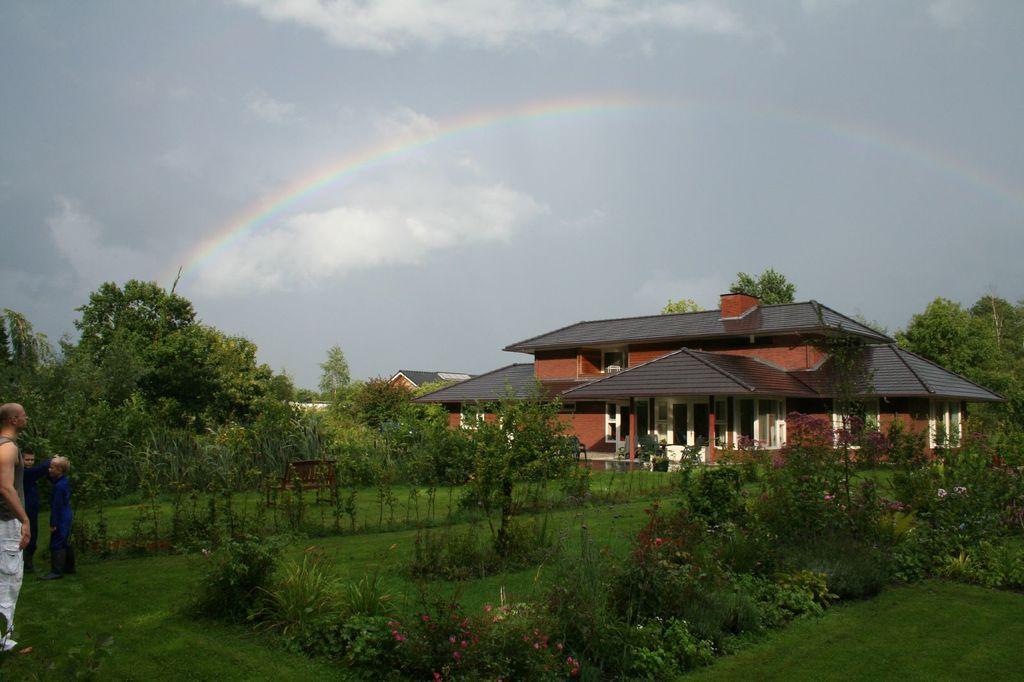Could you give a brief overview of what you see in this image? On the left side of the image we can see a group of people standing on grass field. In the center of the image we can see some plants, a bench is placed on the ground. On the right side of the image we can see buildings with windows and roofs. In the background, we can see some trees and a rainbow in the sky. 